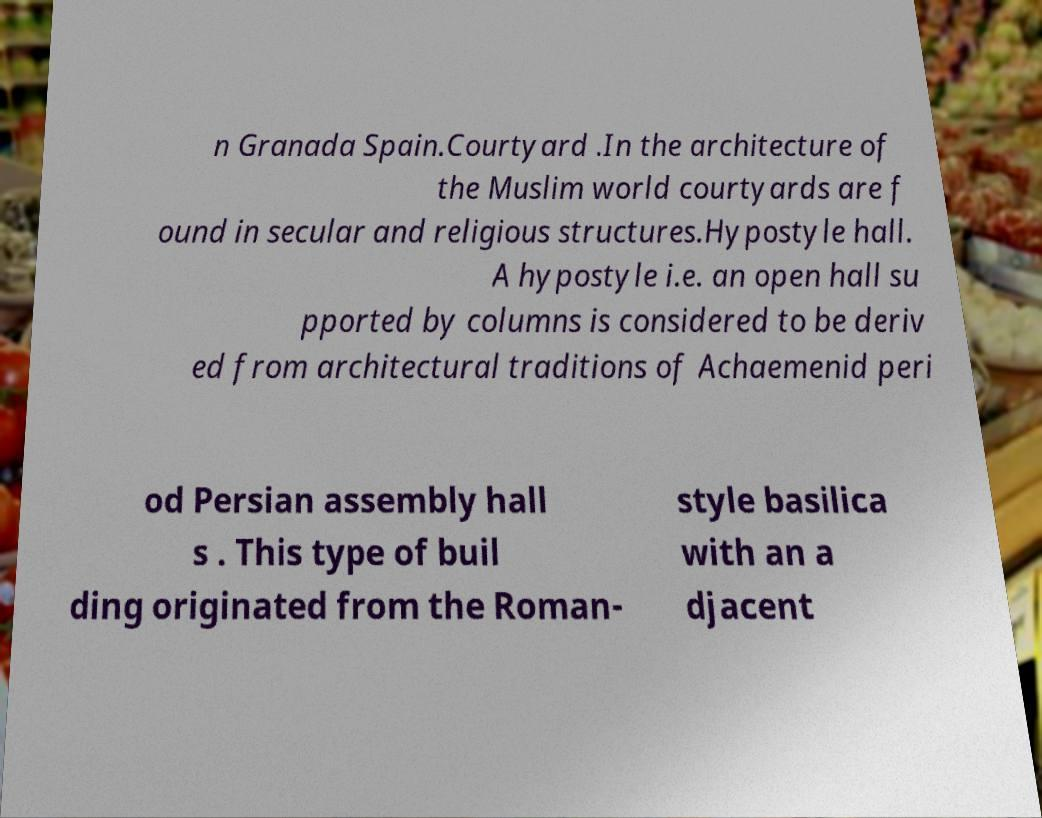Can you read and provide the text displayed in the image?This photo seems to have some interesting text. Can you extract and type it out for me? n Granada Spain.Courtyard .In the architecture of the Muslim world courtyards are f ound in secular and religious structures.Hypostyle hall. A hypostyle i.e. an open hall su pported by columns is considered to be deriv ed from architectural traditions of Achaemenid peri od Persian assembly hall s . This type of buil ding originated from the Roman- style basilica with an a djacent 